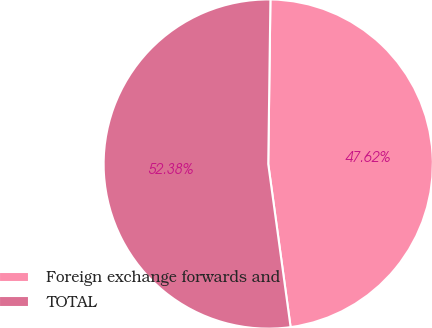Convert chart to OTSL. <chart><loc_0><loc_0><loc_500><loc_500><pie_chart><fcel>Foreign exchange forwards and<fcel>TOTAL<nl><fcel>47.62%<fcel>52.38%<nl></chart> 